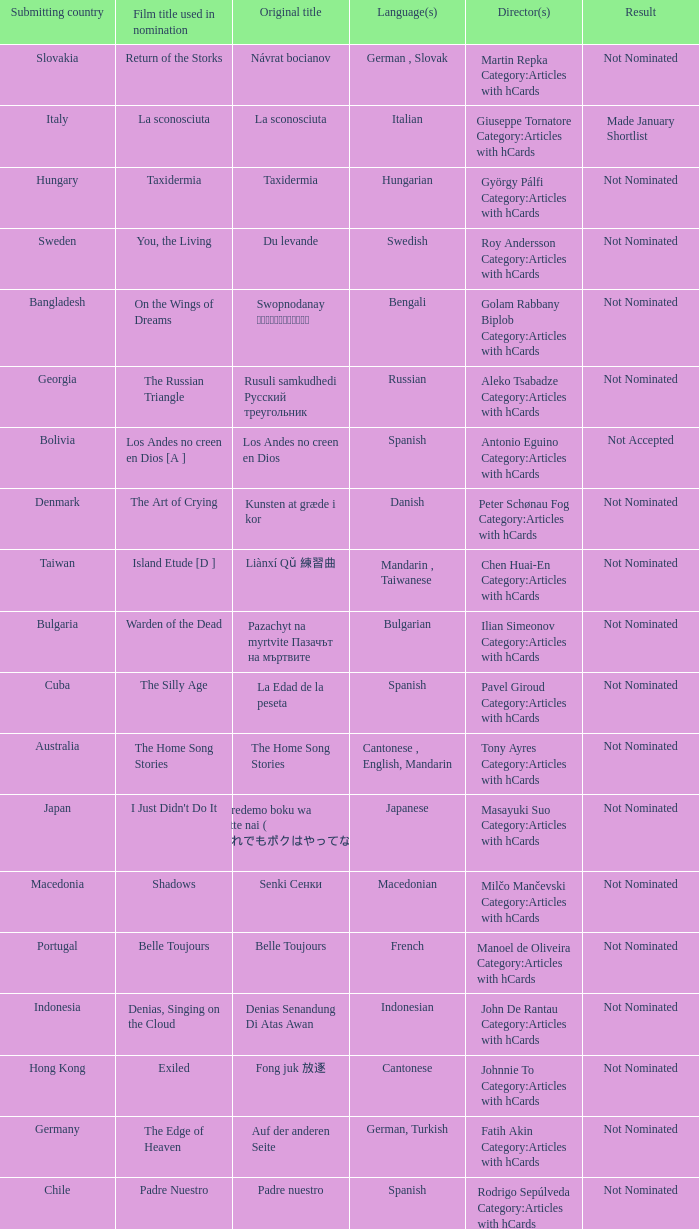What country submitted miehen työ? Finland. 